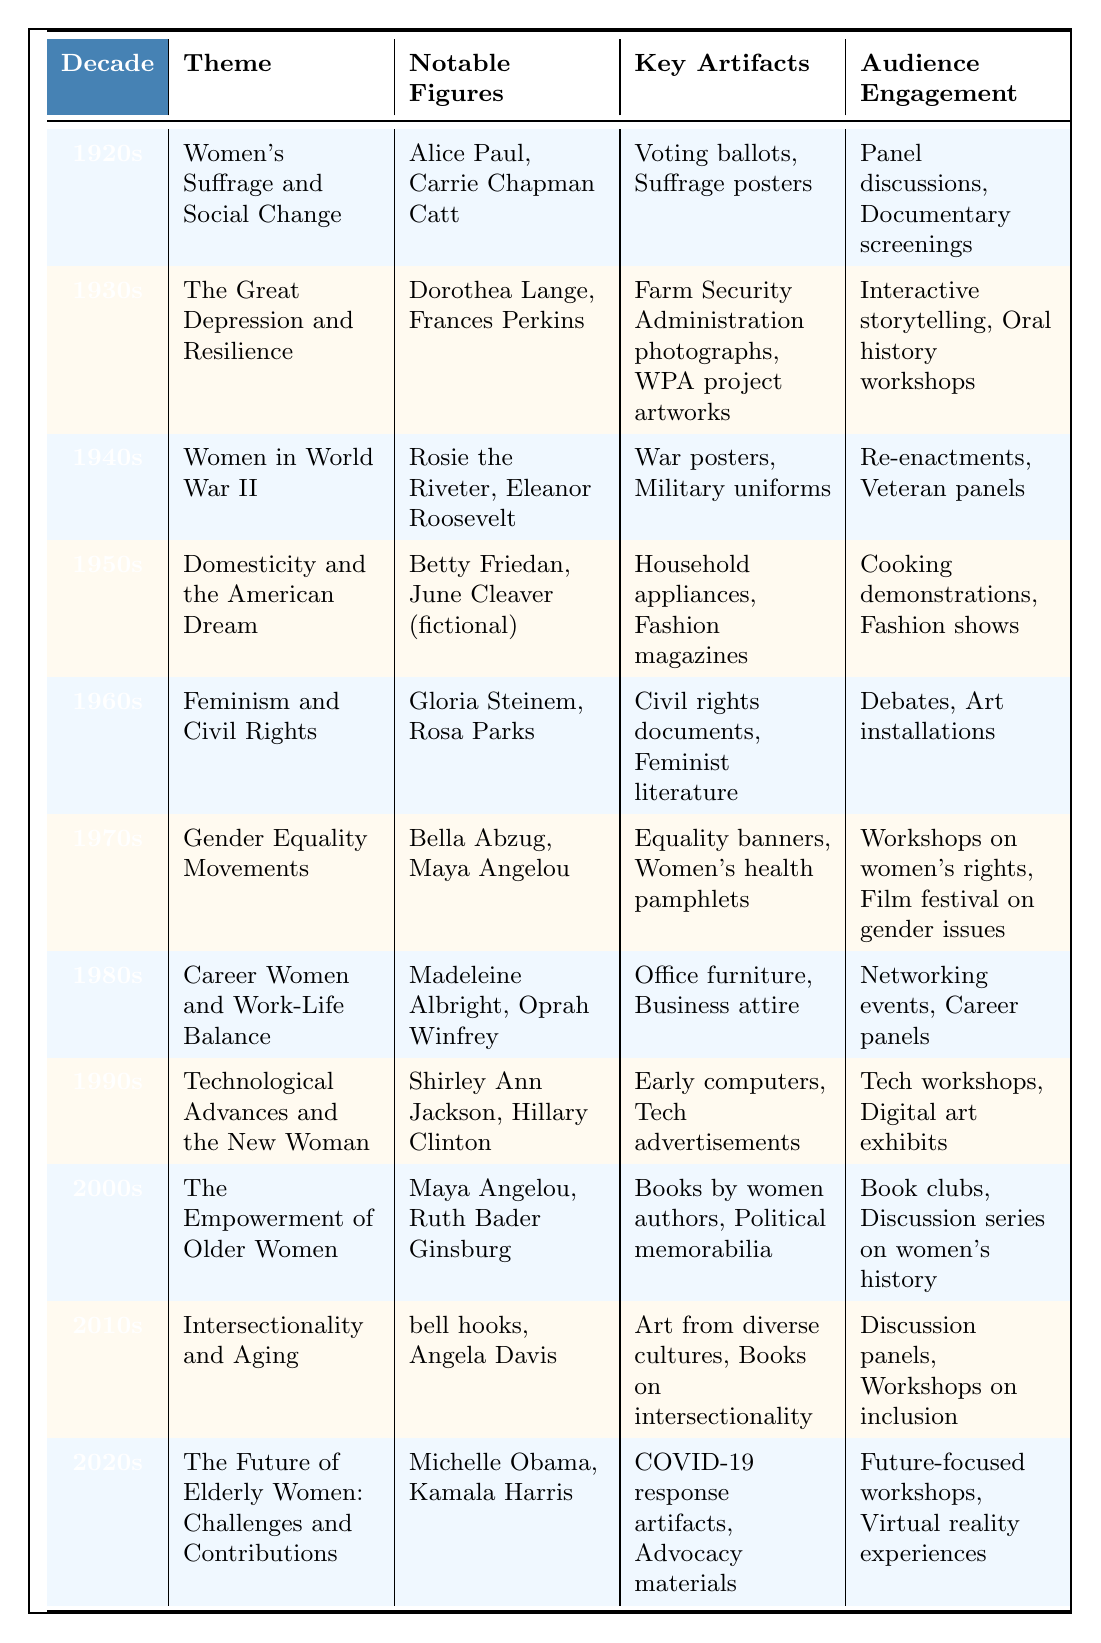What was the theme of the 1950s exhibition? The table directly states that the theme for the 1950s is "Domesticity and the American Dream."
Answer: Domesticity and the American Dream Which notable figures are associated with the theme of the 1960s? By looking at the table under the 1960s row, the notable figures listed are "Gloria Steinem" and "Rosa Parks."
Answer: Gloria Steinem, Rosa Parks Did the 1980s exhibitions focus on women's rights or work-life balance? The table indicates that the theme of the 1980s was "Career Women and Work-Life Balance," not specifically women's rights.
Answer: No In which decade did the exhibition include artifacts related to World War II? According to the table, the 1940s exhibition theme is "Women in World War II," which includes artifacts like war posters and military uniforms.
Answer: 1940s How many themes are mentioned for the 1970s and 1980s combined? From the table, the 1970s has one theme ("Gender Equality Movements") and the 1980s has another theme ("Career Women and Work-Life Balance"). Thus, the total is 1 + 1 = 2 themes.
Answer: 2 What types of audience engagement were featured in the 2010s exhibition? The table indicates that the 2010s exhibition included "Discussion panels" and "Workshops on inclusion" as forms of audience engagement.
Answer: Discussion panels, Workshops on inclusion Is there a notable figure who appeared in both the 2000s and 2010s exhibitions? The notable figure "Maya Angelou" appears in both the 2000s ("The Empowerment of Older Women") and the 1970s, but not in the 2010s. Thus, the answer is yes, she appeared in the 2000s.
Answer: Yes Which decade's exhibition focused on the "COVID-19 response artifacts"? As per the table, the 2020s exhibition theme specifically includes "COVID-19 response artifacts," making it the decade in focus.
Answer: 2020s Find the decade with the maximum potential for technological advancements. Comparing the themes, the 1990s exhibit titled "Technological Advances and the New Woman" specifically indicates the focus on technology, hence it stands out as having the maximum potential.
Answer: 1990s 